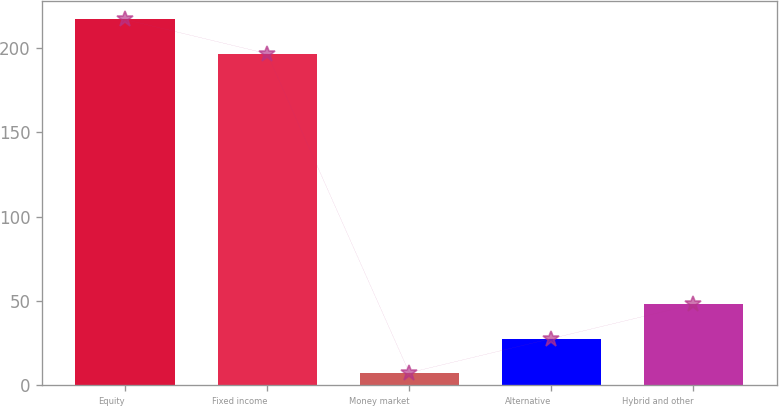Convert chart. <chart><loc_0><loc_0><loc_500><loc_500><bar_chart><fcel>Equity<fcel>Fixed income<fcel>Money market<fcel>Alternative<fcel>Hybrid and other<nl><fcel>216.74<fcel>196.5<fcel>7.5<fcel>27.74<fcel>47.98<nl></chart> 